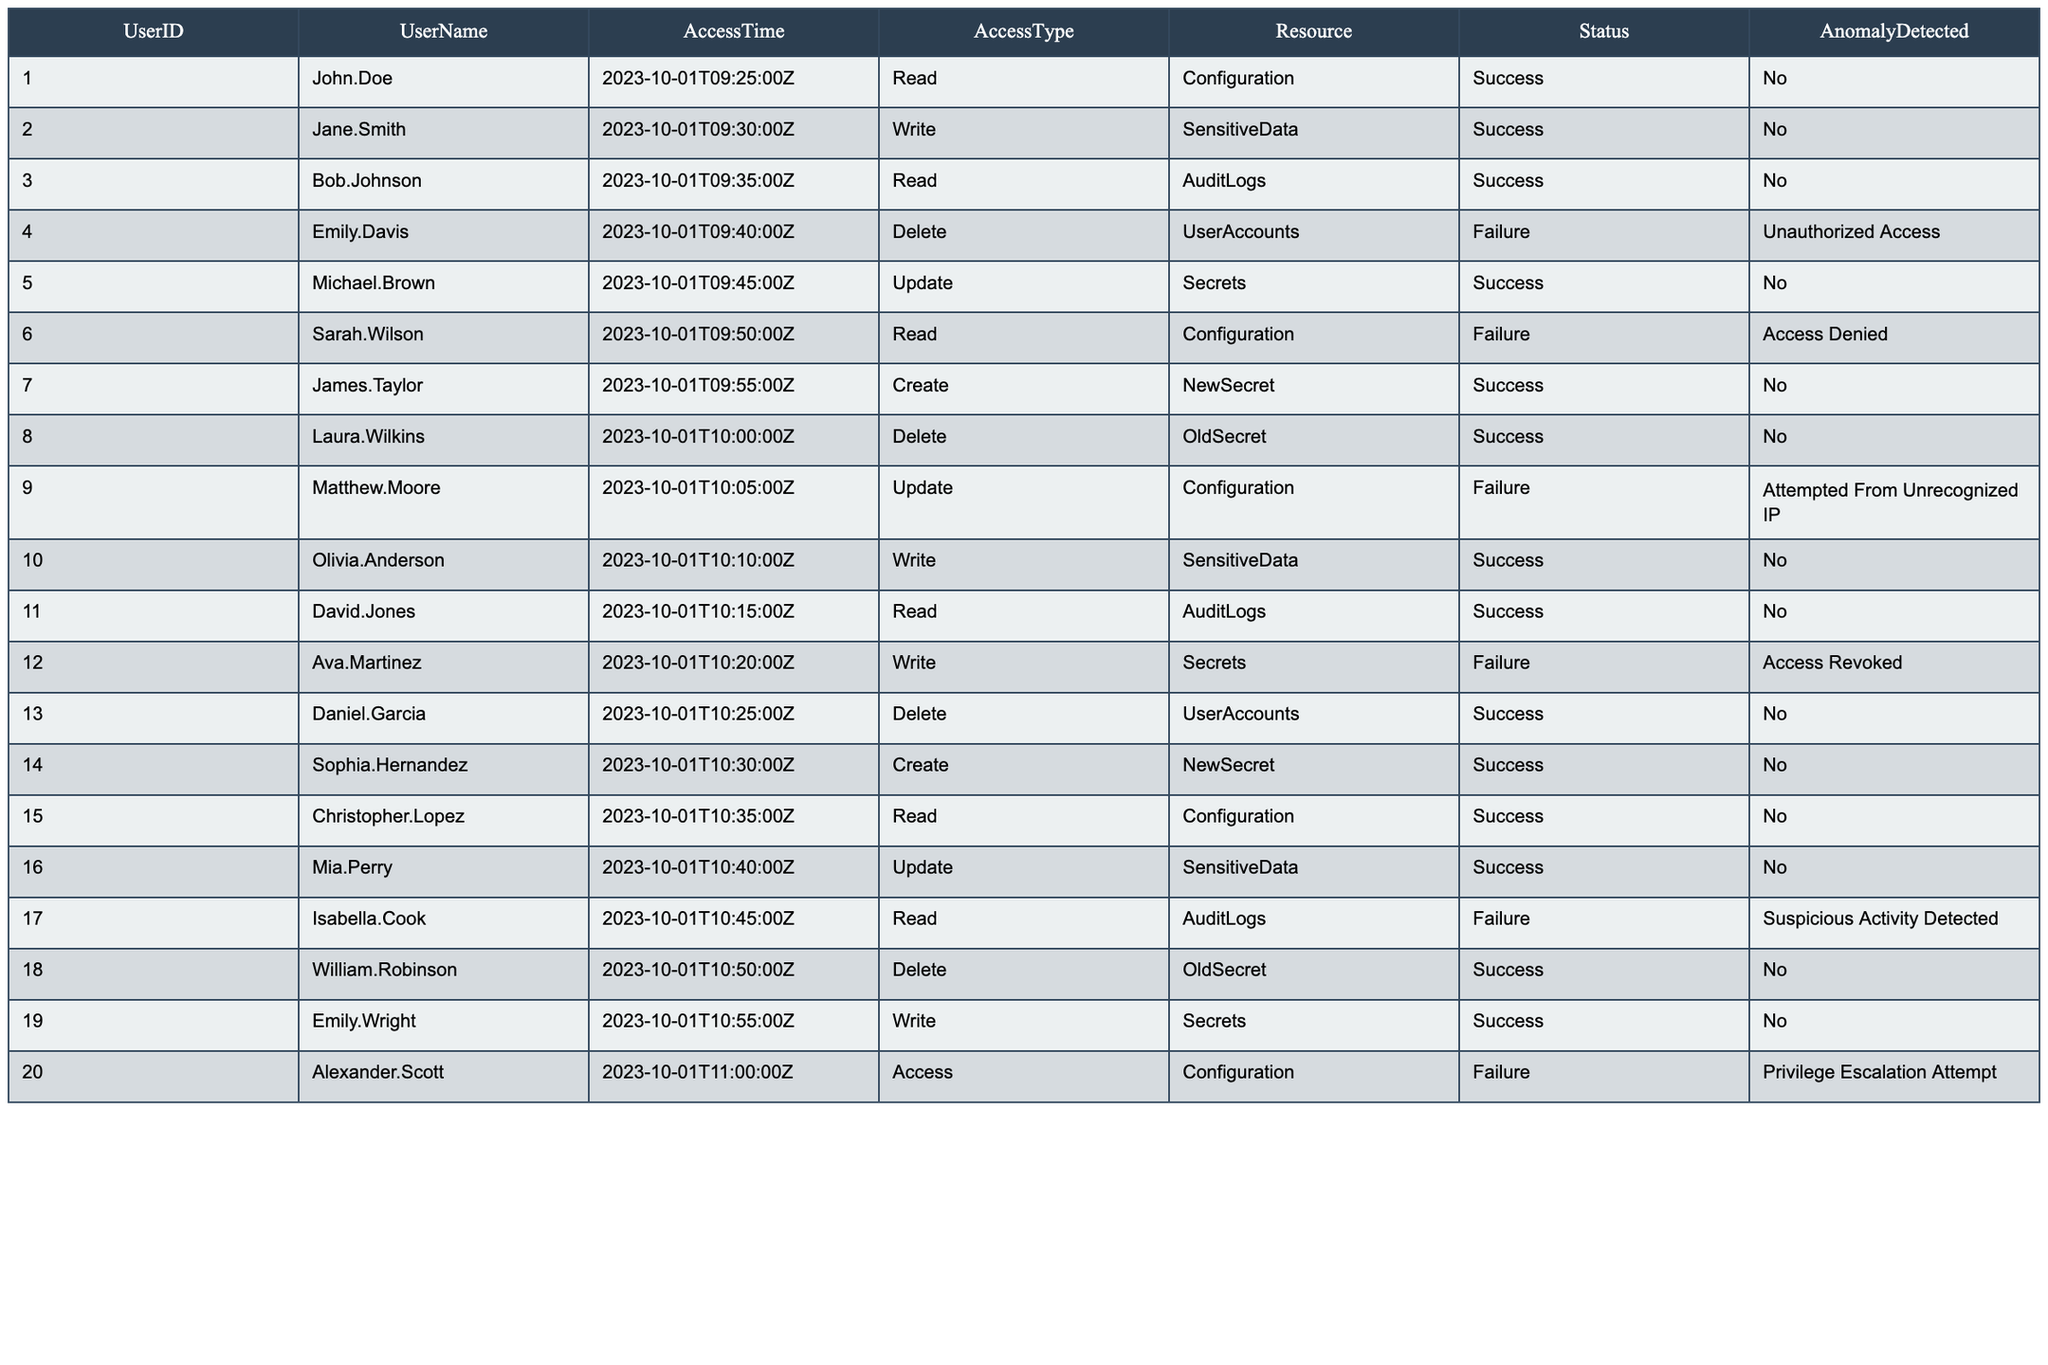What is the total number of successful access attempts? By counting all the rows with the Status labeled as "Success", we see that there are 15 successful access attempts listed in the table.
Answer: 15 How many users received a status of "Unauthorized Access"? There is one entry in the table with the Status "Unauthorized Access" corresponding to Emily Davis.
Answer: 1 Which user had an access attempt marked with "Suspicious Activity Detected"? Looking through the rows, we find that Isabella Cook's access attempt had this specific anomaly detected.
Answer: Isabella Cook What percentage of access attempts resulted in failures? There are 20 total access attempts, and 5 of them failed (including "Unauthorized Access" and other failures). Therefore, the failure percentage is (5/20) * 100 = 25%.
Answer: 25% Was there any access attempt to write to Sensitive Data that was unsuccessful? Yes, we see that Ava Martinez tried to write to Secrets, and this attempt was marked as a failure (status).
Answer: Yes How many distinct anomalies were detected? By reviewing the AnomalyDetected column, we find 5 distinct types of anomalies: Unauthorized Access, Access Denied, Attempted From Unrecognized IP, Access Revoked, Suspicious Activity Detected, and Privilege Escalation Attempt.
Answer: 6 Who accessed the AuditLogs successfully? The users who successfully accessed the AuditLogs are John Doe, Bob Johnson, and David Jones.
Answer: John Doe, Bob Johnson, David Jones Which resource had the highest number of unsuccessful access attempts? The resource "UserAccounts" shows two unsuccessful attempts (Emily Davis and Daniel Garcia).
Answer: UserAccounts What was the status of Sarah Wilson's access attempt? Sarah Wilson's access attempt was marked as "Failure" with the reason listed as "Access Denied".
Answer: Failure Which time slot had a successful Create access attempt? The time slots for successful Create attempts are 09:55:00Z (James Taylor) and 10:30:00Z (Sophia Hernandez).
Answer: 09:55:00Z and 10:30:00Z 